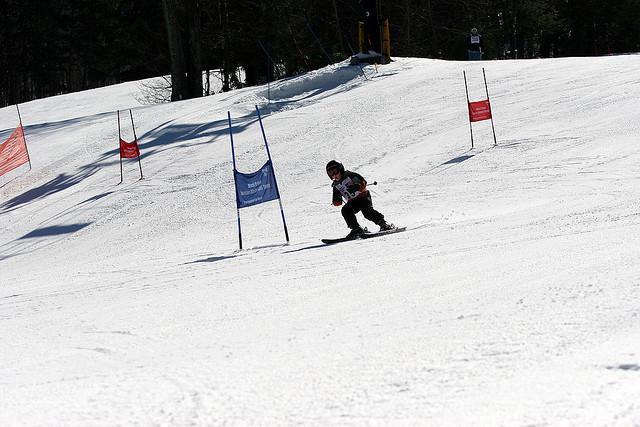What is the boy doing?
From the following four choices, select the correct answer to address the question.
Options: Stretching, running, descending, ascending. Descending. 